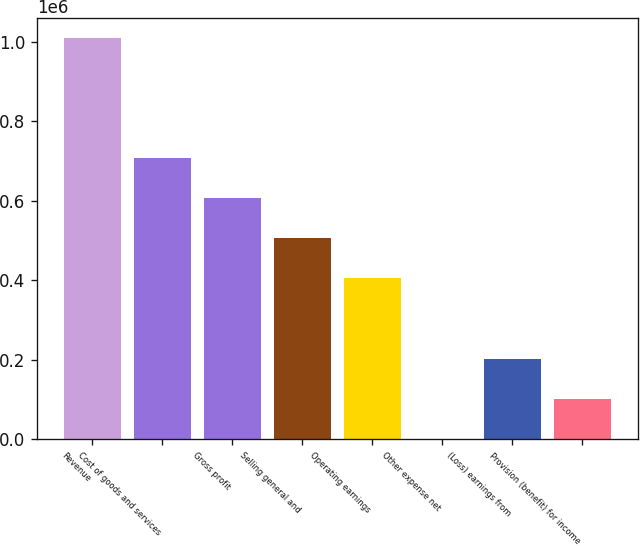Convert chart. <chart><loc_0><loc_0><loc_500><loc_500><bar_chart><fcel>Revenue<fcel>Cost of goods and services<fcel>Gross profit<fcel>Selling general and<fcel>Operating earnings<fcel>Other expense net<fcel>(Loss) earnings from<fcel>Provision (benefit) for income<nl><fcel>1.01014e+06<fcel>707379<fcel>606461<fcel>505542<fcel>404623<fcel>949<fcel>202786<fcel>101868<nl></chart> 